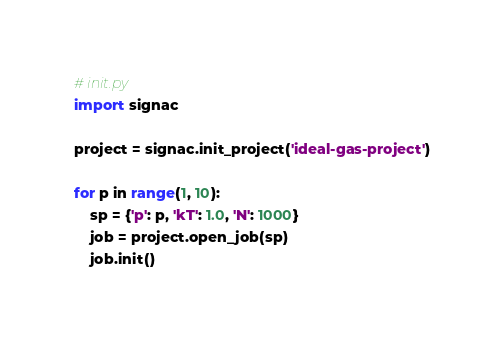<code> <loc_0><loc_0><loc_500><loc_500><_Python_># init.py
import signac

project = signac.init_project('ideal-gas-project')

for p in range(1, 10):
    sp = {'p': p, 'kT': 1.0, 'N': 1000}
    job = project.open_job(sp)
    job.init()
</code> 